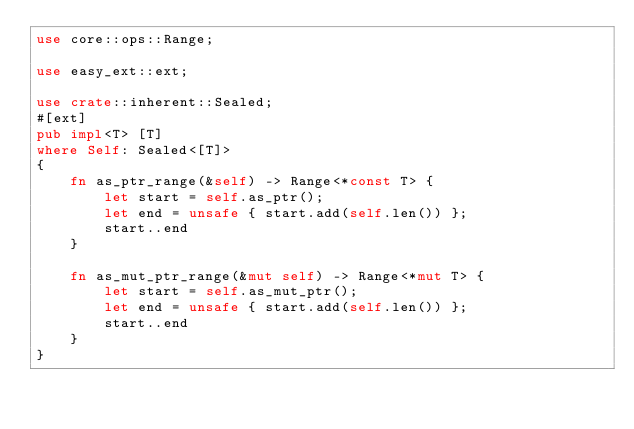<code> <loc_0><loc_0><loc_500><loc_500><_Rust_>use core::ops::Range;

use easy_ext::ext;

use crate::inherent::Sealed;
#[ext]
pub impl<T> [T]
where Self: Sealed<[T]>
{
    fn as_ptr_range(&self) -> Range<*const T> {
        let start = self.as_ptr();
        let end = unsafe { start.add(self.len()) };
        start..end
    }

    fn as_mut_ptr_range(&mut self) -> Range<*mut T> {
        let start = self.as_mut_ptr();
        let end = unsafe { start.add(self.len()) };
        start..end
    }
}
</code> 